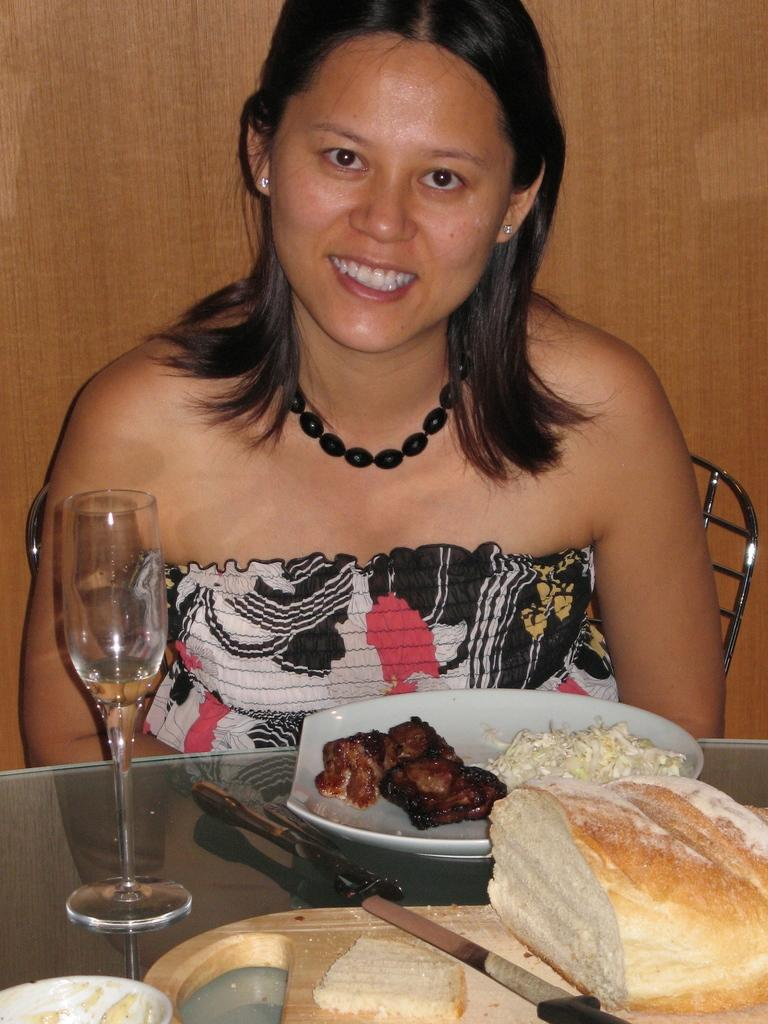What is the woman doing in the image? The woman is sitting and smiling in the image. What is the woman sitting on? The woman is sitting in a chair. What can be seen on the table in the image? There is a chop board, plates, food, a fork, a knife, bread, and a glass on the table. What type of material is the background made of? The background of the image is wooden. What type of paint is the woman using to create a profit in the image? There is no paint or mention of profit in the image; it features a woman sitting and smiling with various items on a table. What type of blade is the woman using to cut the bread in the image? There is no blade visible in the image; it only shows a knife on the table. 